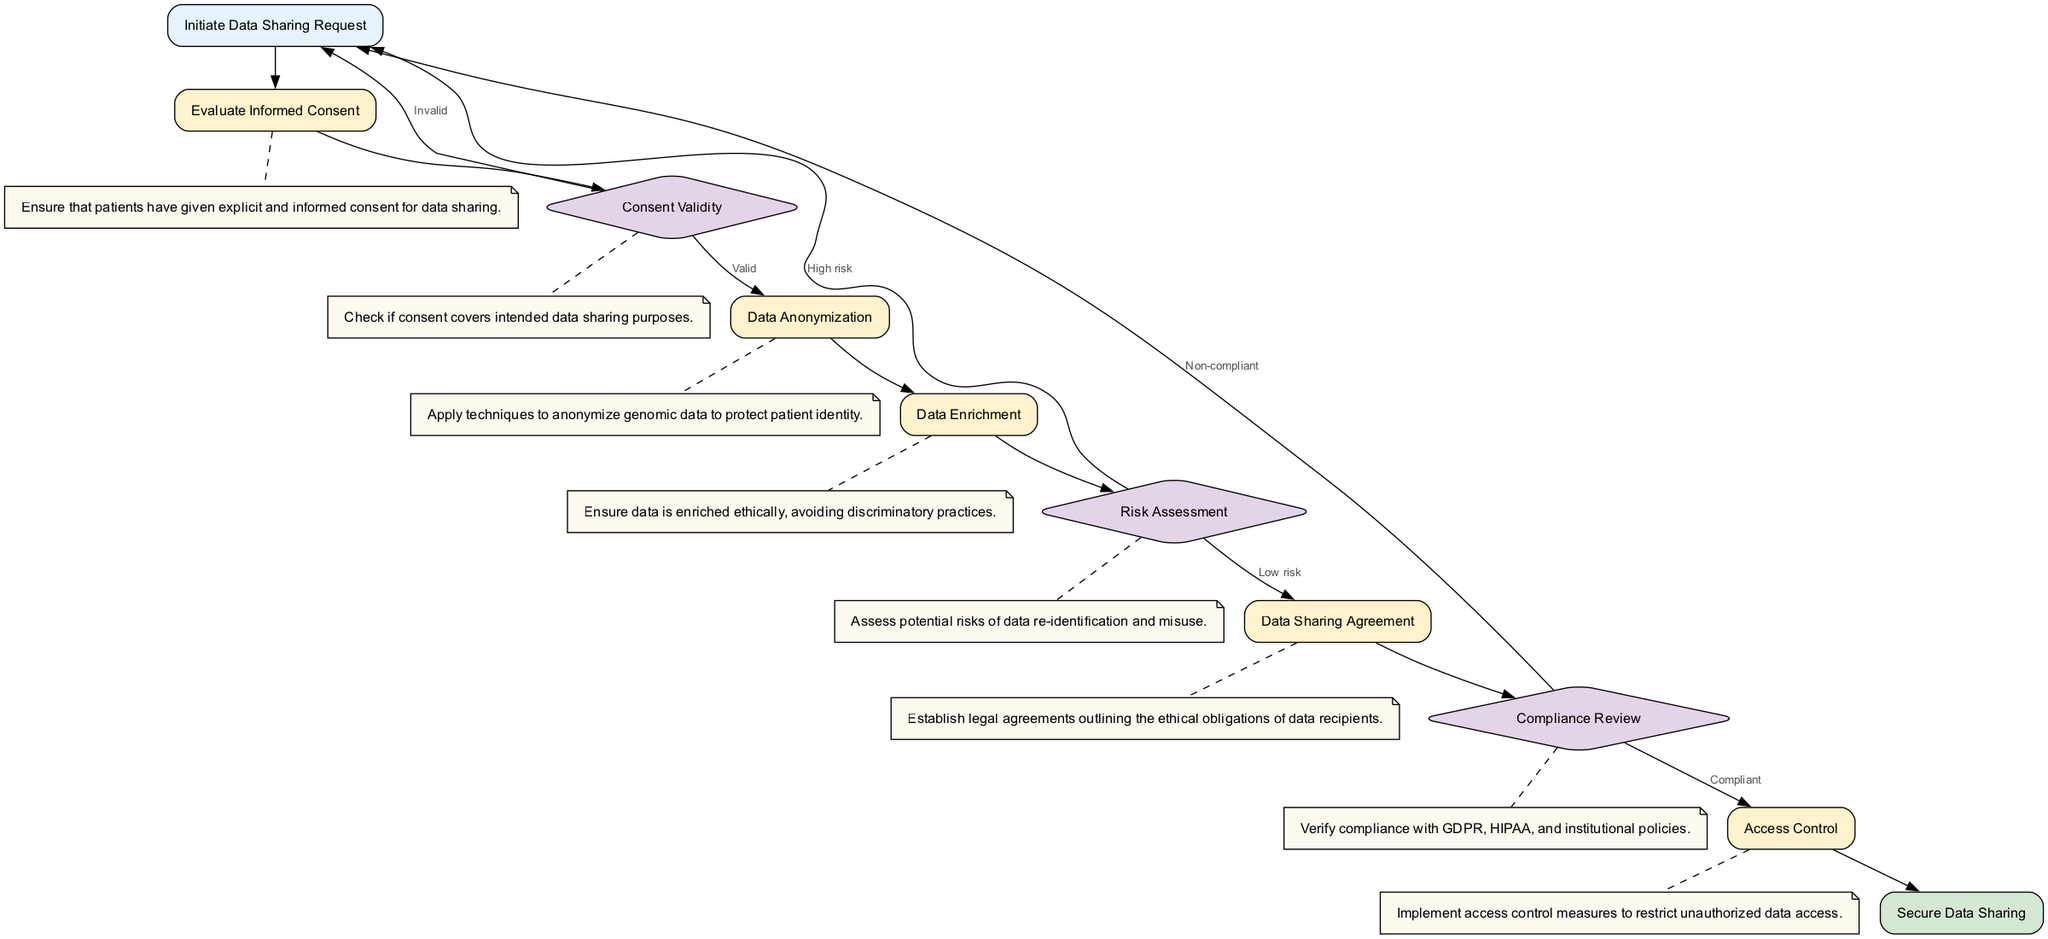What is the first step in the pathway? The first step listed in the diagram is "Initiate Data Sharing Request," which is denoted as the starting point of the process.
Answer: Initiate Data Sharing Request How many decision nodes are present in the diagram? The diagram contains three decision nodes: "Consent Validity," "Risk Assessment," and "Compliance Review," which can be counted directly by identifying the nodes labeled as decisions.
Answer: 3 What follows after "Evaluate Informed Consent"? After "Evaluate Informed Consent," the next step is "Consent Validity," which is indicated by the directed edge connecting these two nodes in the pathway.
Answer: Consent Validity What is the output if the consent is invalid? If the consent is invalid, the pathway loops back to "Initiate Data Sharing Request," indicating that a new request must be initiated. This outcome is clearly stated on the edge labeled 'Invalid' that leads back to the starting node.
Answer: Initiate Data Sharing Request What is the process following a low-risk assessment? Following a low-risk assessment, the next process is "Data Sharing Agreement," as depicted by the directed edge from the "Risk Assessment" decision node to the processing node representing this step.
Answer: Data Sharing Agreement What is the significance of the "Data Sharing Agreement" in the diagram? The "Data Sharing Agreement" establishes legal obligations for data recipients, highlighting its role in ensuring ethical adherence during data sharing, which is a crucial step in the pathway.
Answer: Establish legal agreements What happens if compliance is not verified? If compliance is not verified during the "Compliance Review," the flow leads back to "Initiate Data Sharing Request," which signifies that the process cannot continue without ensuring compliance with regulations.
Answer: Initiate Data Sharing Request What is the final step in the diagram? The final step indicated in the pathway is "Secure Data Sharing," which marks the completion of the data sharing process after all prior steps have been successfully navigated.
Answer: Secure Data Sharing 